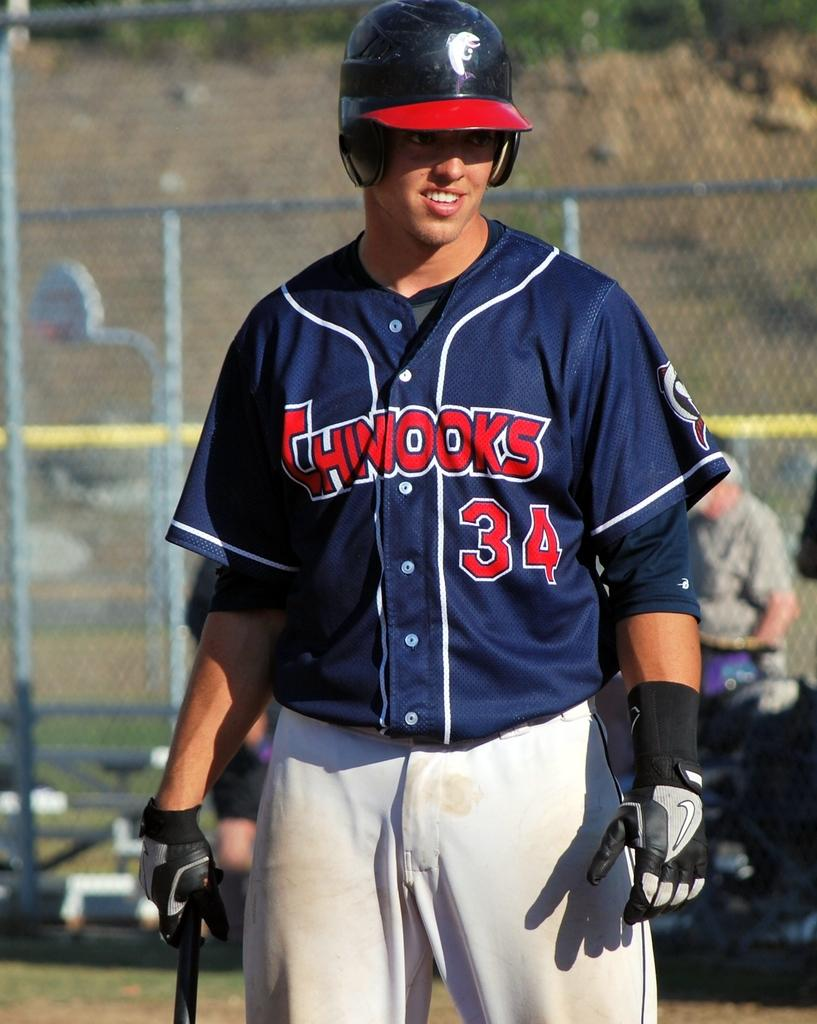Provide a one-sentence caption for the provided image. A man wearing a blue Chinooks jersey and batters cap. 